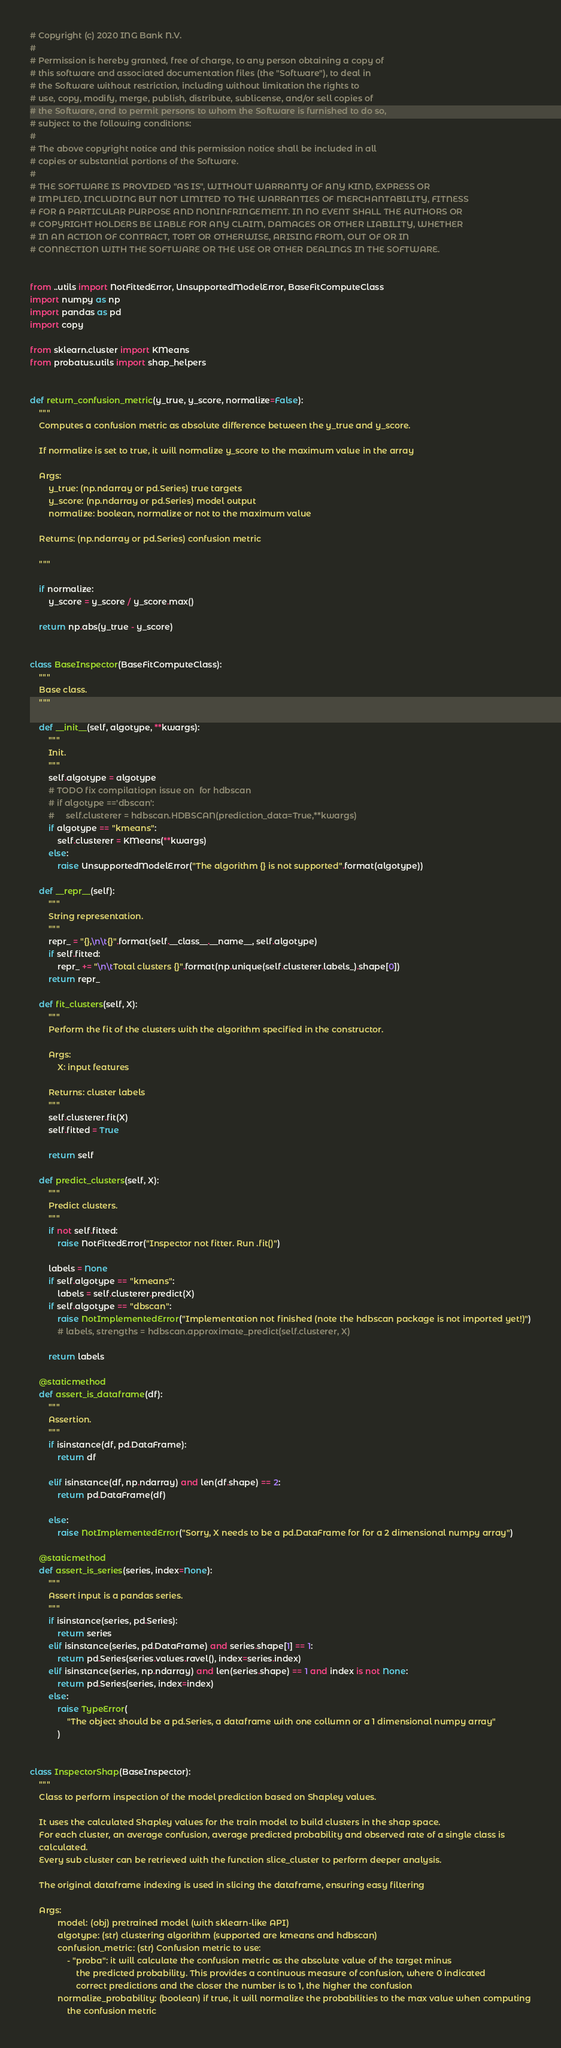Convert code to text. <code><loc_0><loc_0><loc_500><loc_500><_Python_># Copyright (c) 2020 ING Bank N.V.
#
# Permission is hereby granted, free of charge, to any person obtaining a copy of
# this software and associated documentation files (the "Software"), to deal in
# the Software without restriction, including without limitation the rights to
# use, copy, modify, merge, publish, distribute, sublicense, and/or sell copies of
# the Software, and to permit persons to whom the Software is furnished to do so,
# subject to the following conditions:
#
# The above copyright notice and this permission notice shall be included in all
# copies or substantial portions of the Software.
#
# THE SOFTWARE IS PROVIDED "AS IS", WITHOUT WARRANTY OF ANY KIND, EXPRESS OR
# IMPLIED, INCLUDING BUT NOT LIMITED TO THE WARRANTIES OF MERCHANTABILITY, FITNESS
# FOR A PARTICULAR PURPOSE AND NONINFRINGEMENT. IN NO EVENT SHALL THE AUTHORS OR
# COPYRIGHT HOLDERS BE LIABLE FOR ANY CLAIM, DAMAGES OR OTHER LIABILITY, WHETHER
# IN AN ACTION OF CONTRACT, TORT OR OTHERWISE, ARISING FROM, OUT OF OR IN
# CONNECTION WITH THE SOFTWARE OR THE USE OR OTHER DEALINGS IN THE SOFTWARE.


from ..utils import NotFittedError, UnsupportedModelError, BaseFitComputeClass
import numpy as np
import pandas as pd
import copy

from sklearn.cluster import KMeans
from probatus.utils import shap_helpers


def return_confusion_metric(y_true, y_score, normalize=False):
    """
    Computes a confusion metric as absolute difference between the y_true and y_score.

    If normalize is set to true, it will normalize y_score to the maximum value in the array

    Args:
        y_true: (np.ndarray or pd.Series) true targets
        y_score: (np.ndarray or pd.Series) model output
        normalize: boolean, normalize or not to the maximum value

    Returns: (np.ndarray or pd.Series) confusion metric

    """

    if normalize:
        y_score = y_score / y_score.max()

    return np.abs(y_true - y_score)


class BaseInspector(BaseFitComputeClass):
    """
    Base class.
    """

    def __init__(self, algotype, **kwargs):
        """
        Init.
        """
        self.algotype = algotype
        # TODO fix compilatiopn issue on  for hdbscan
        # if algotype =='dbscan':
        #     self.clusterer = hdbscan.HDBSCAN(prediction_data=True,**kwargs)
        if algotype == "kmeans":
            self.clusterer = KMeans(**kwargs)
        else:
            raise UnsupportedModelError("The algorithm {} is not supported".format(algotype))

    def __repr__(self):
        """
        String representation.
        """
        repr_ = "{},\n\t{}".format(self.__class__.__name__, self.algotype)
        if self.fitted:
            repr_ += "\n\tTotal clusters {}".format(np.unique(self.clusterer.labels_).shape[0])
        return repr_

    def fit_clusters(self, X):
        """
        Perform the fit of the clusters with the algorithm specified in the constructor.

        Args:
            X: input features

        Returns: cluster labels
        """
        self.clusterer.fit(X)
        self.fitted = True

        return self

    def predict_clusters(self, X):
        """
        Predict clusters.
        """
        if not self.fitted:
            raise NotFittedError("Inspector not fitter. Run .fit()")

        labels = None
        if self.algotype == "kmeans":
            labels = self.clusterer.predict(X)
        if self.algotype == "dbscan":
            raise NotImplementedError("Implementation not finished (note the hdbscan package is not imported yet!)")
            # labels, strengths = hdbscan.approximate_predict(self.clusterer, X)

        return labels

    @staticmethod
    def assert_is_dataframe(df):
        """
        Assertion.
        """
        if isinstance(df, pd.DataFrame):
            return df

        elif isinstance(df, np.ndarray) and len(df.shape) == 2:
            return pd.DataFrame(df)

        else:
            raise NotImplementedError("Sorry, X needs to be a pd.DataFrame for for a 2 dimensional numpy array")

    @staticmethod
    def assert_is_series(series, index=None):
        """
        Assert input is a pandas series.
        """
        if isinstance(series, pd.Series):
            return series
        elif isinstance(series, pd.DataFrame) and series.shape[1] == 1:
            return pd.Series(series.values.ravel(), index=series.index)
        elif isinstance(series, np.ndarray) and len(series.shape) == 1 and index is not None:
            return pd.Series(series, index=index)
        else:
            raise TypeError(
                "The object should be a pd.Series, a dataframe with one collumn or a 1 dimensional numpy array"
            )


class InspectorShap(BaseInspector):
    """
    Class to perform inspection of the model prediction based on Shapley values.

    It uses the calculated Shapley values for the train model to build clusters in the shap space.
    For each cluster, an average confusion, average predicted probability and observed rate of a single class is
    calculated.
    Every sub cluster can be retrieved with the function slice_cluster to perform deeper analysis.

    The original dataframe indexing is used in slicing the dataframe, ensuring easy filtering

    Args:
            model: (obj) pretrained model (with sklearn-like API)
            algotype: (str) clustering algorithm (supported are kmeans and hdbscan)
            confusion_metric: (str) Confusion metric to use:
                - "proba": it will calculate the confusion metric as the absolute value of the target minus
                    the predicted probability. This provides a continuous measure of confusion, where 0 indicated
                    correct predictions and the closer the number is to 1, the higher the confusion
            normalize_probability: (boolean) if true, it will normalize the probabilities to the max value when computing
                the confusion metric</code> 